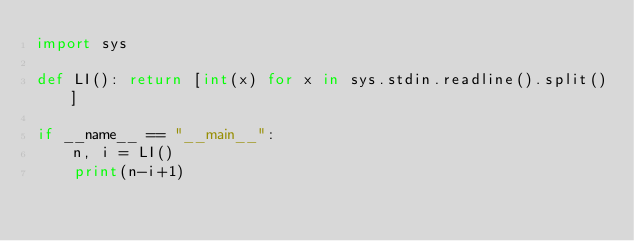<code> <loc_0><loc_0><loc_500><loc_500><_Python_>import sys

def LI(): return [int(x) for x in sys.stdin.readline().split()]

if __name__ == "__main__":
    n, i = LI()
    print(n-i+1)</code> 